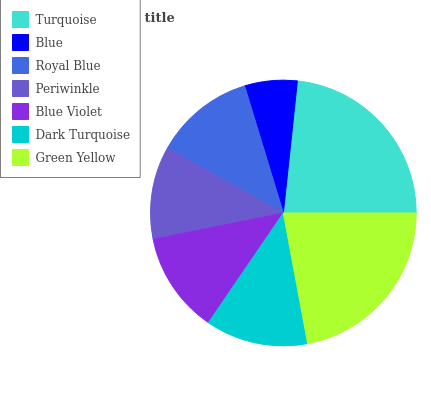Is Blue the minimum?
Answer yes or no. Yes. Is Turquoise the maximum?
Answer yes or no. Yes. Is Royal Blue the minimum?
Answer yes or no. No. Is Royal Blue the maximum?
Answer yes or no. No. Is Royal Blue greater than Blue?
Answer yes or no. Yes. Is Blue less than Royal Blue?
Answer yes or no. Yes. Is Blue greater than Royal Blue?
Answer yes or no. No. Is Royal Blue less than Blue?
Answer yes or no. No. Is Blue Violet the high median?
Answer yes or no. Yes. Is Blue Violet the low median?
Answer yes or no. Yes. Is Royal Blue the high median?
Answer yes or no. No. Is Royal Blue the low median?
Answer yes or no. No. 